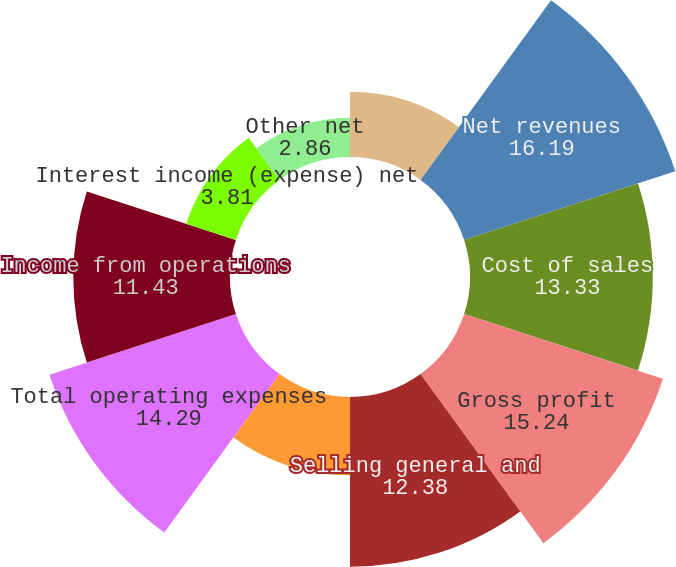Convert chart to OTSL. <chart><loc_0><loc_0><loc_500><loc_500><pie_chart><fcel>(In thousands except per share<fcel>Net revenues<fcel>Cost of sales<fcel>Gross profit<fcel>Selling general and<fcel>Research and development<fcel>Total operating expenses<fcel>Income from operations<fcel>Interest income (expense) net<fcel>Other net<nl><fcel>4.76%<fcel>16.19%<fcel>13.33%<fcel>15.24%<fcel>12.38%<fcel>5.71%<fcel>14.29%<fcel>11.43%<fcel>3.81%<fcel>2.86%<nl></chart> 